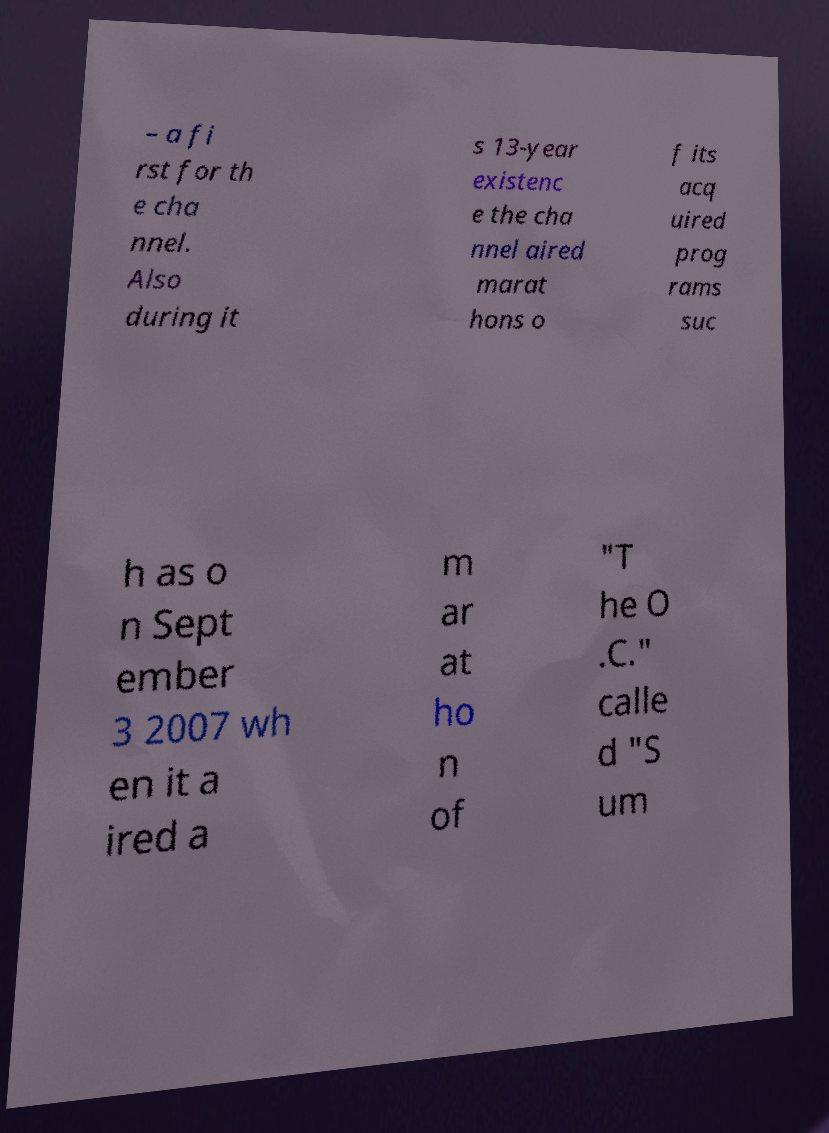I need the written content from this picture converted into text. Can you do that? – a fi rst for th e cha nnel. Also during it s 13-year existenc e the cha nnel aired marat hons o f its acq uired prog rams suc h as o n Sept ember 3 2007 wh en it a ired a m ar at ho n of "T he O .C." calle d "S um 